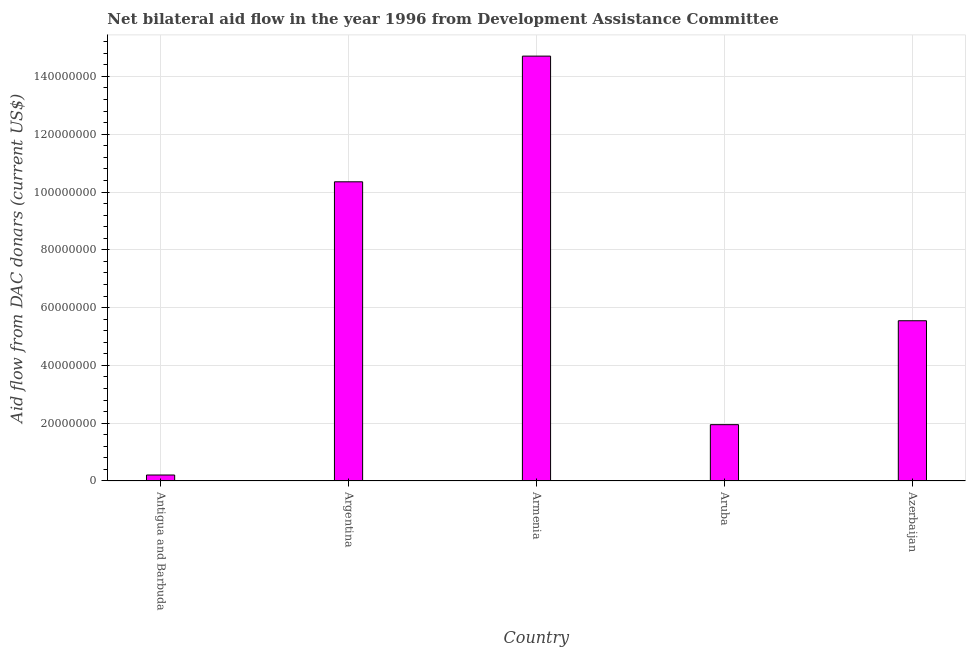Does the graph contain any zero values?
Make the answer very short. No. Does the graph contain grids?
Your response must be concise. Yes. What is the title of the graph?
Make the answer very short. Net bilateral aid flow in the year 1996 from Development Assistance Committee. What is the label or title of the X-axis?
Ensure brevity in your answer.  Country. What is the label or title of the Y-axis?
Offer a very short reply. Aid flow from DAC donars (current US$). What is the net bilateral aid flows from dac donors in Azerbaijan?
Make the answer very short. 5.54e+07. Across all countries, what is the maximum net bilateral aid flows from dac donors?
Your answer should be compact. 1.47e+08. Across all countries, what is the minimum net bilateral aid flows from dac donors?
Give a very brief answer. 2.07e+06. In which country was the net bilateral aid flows from dac donors maximum?
Your answer should be compact. Armenia. In which country was the net bilateral aid flows from dac donors minimum?
Your response must be concise. Antigua and Barbuda. What is the sum of the net bilateral aid flows from dac donors?
Your answer should be very brief. 3.28e+08. What is the difference between the net bilateral aid flows from dac donors in Antigua and Barbuda and Aruba?
Keep it short and to the point. -1.74e+07. What is the average net bilateral aid flows from dac donors per country?
Your answer should be very brief. 6.55e+07. What is the median net bilateral aid flows from dac donors?
Give a very brief answer. 5.54e+07. In how many countries, is the net bilateral aid flows from dac donors greater than 140000000 US$?
Provide a short and direct response. 1. What is the ratio of the net bilateral aid flows from dac donors in Antigua and Barbuda to that in Armenia?
Provide a short and direct response. 0.01. Is the difference between the net bilateral aid flows from dac donors in Antigua and Barbuda and Argentina greater than the difference between any two countries?
Offer a terse response. No. What is the difference between the highest and the second highest net bilateral aid flows from dac donors?
Your answer should be very brief. 4.35e+07. Is the sum of the net bilateral aid flows from dac donors in Armenia and Aruba greater than the maximum net bilateral aid flows from dac donors across all countries?
Give a very brief answer. Yes. What is the difference between the highest and the lowest net bilateral aid flows from dac donors?
Provide a short and direct response. 1.45e+08. In how many countries, is the net bilateral aid flows from dac donors greater than the average net bilateral aid flows from dac donors taken over all countries?
Make the answer very short. 2. How many bars are there?
Give a very brief answer. 5. How many countries are there in the graph?
Provide a short and direct response. 5. What is the difference between two consecutive major ticks on the Y-axis?
Keep it short and to the point. 2.00e+07. Are the values on the major ticks of Y-axis written in scientific E-notation?
Make the answer very short. No. What is the Aid flow from DAC donars (current US$) in Antigua and Barbuda?
Ensure brevity in your answer.  2.07e+06. What is the Aid flow from DAC donars (current US$) in Argentina?
Make the answer very short. 1.04e+08. What is the Aid flow from DAC donars (current US$) of Armenia?
Provide a succinct answer. 1.47e+08. What is the Aid flow from DAC donars (current US$) in Aruba?
Your answer should be compact. 1.95e+07. What is the Aid flow from DAC donars (current US$) in Azerbaijan?
Keep it short and to the point. 5.54e+07. What is the difference between the Aid flow from DAC donars (current US$) in Antigua and Barbuda and Argentina?
Your response must be concise. -1.01e+08. What is the difference between the Aid flow from DAC donars (current US$) in Antigua and Barbuda and Armenia?
Your answer should be very brief. -1.45e+08. What is the difference between the Aid flow from DAC donars (current US$) in Antigua and Barbuda and Aruba?
Provide a short and direct response. -1.74e+07. What is the difference between the Aid flow from DAC donars (current US$) in Antigua and Barbuda and Azerbaijan?
Offer a terse response. -5.34e+07. What is the difference between the Aid flow from DAC donars (current US$) in Argentina and Armenia?
Ensure brevity in your answer.  -4.35e+07. What is the difference between the Aid flow from DAC donars (current US$) in Argentina and Aruba?
Ensure brevity in your answer.  8.40e+07. What is the difference between the Aid flow from DAC donars (current US$) in Argentina and Azerbaijan?
Your answer should be compact. 4.81e+07. What is the difference between the Aid flow from DAC donars (current US$) in Armenia and Aruba?
Offer a terse response. 1.28e+08. What is the difference between the Aid flow from DAC donars (current US$) in Armenia and Azerbaijan?
Provide a succinct answer. 9.16e+07. What is the difference between the Aid flow from DAC donars (current US$) in Aruba and Azerbaijan?
Provide a succinct answer. -3.60e+07. What is the ratio of the Aid flow from DAC donars (current US$) in Antigua and Barbuda to that in Armenia?
Ensure brevity in your answer.  0.01. What is the ratio of the Aid flow from DAC donars (current US$) in Antigua and Barbuda to that in Aruba?
Offer a very short reply. 0.11. What is the ratio of the Aid flow from DAC donars (current US$) in Antigua and Barbuda to that in Azerbaijan?
Provide a short and direct response. 0.04. What is the ratio of the Aid flow from DAC donars (current US$) in Argentina to that in Armenia?
Your answer should be very brief. 0.7. What is the ratio of the Aid flow from DAC donars (current US$) in Argentina to that in Aruba?
Keep it short and to the point. 5.31. What is the ratio of the Aid flow from DAC donars (current US$) in Argentina to that in Azerbaijan?
Give a very brief answer. 1.87. What is the ratio of the Aid flow from DAC donars (current US$) in Armenia to that in Aruba?
Ensure brevity in your answer.  7.54. What is the ratio of the Aid flow from DAC donars (current US$) in Armenia to that in Azerbaijan?
Offer a terse response. 2.65. What is the ratio of the Aid flow from DAC donars (current US$) in Aruba to that in Azerbaijan?
Provide a short and direct response. 0.35. 